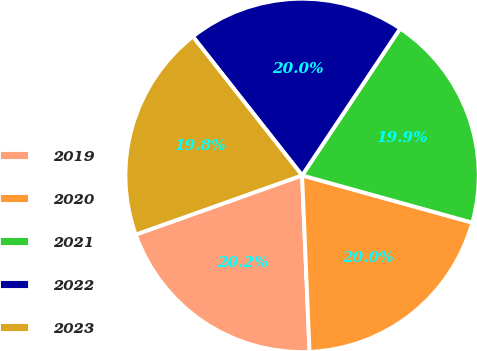<chart> <loc_0><loc_0><loc_500><loc_500><pie_chart><fcel>2019<fcel>2020<fcel>2021<fcel>2022<fcel>2023<nl><fcel>20.23%<fcel>20.02%<fcel>19.94%<fcel>19.98%<fcel>19.83%<nl></chart> 